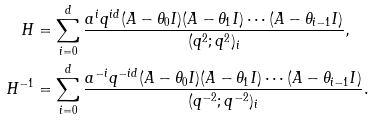<formula> <loc_0><loc_0><loc_500><loc_500>H & = \sum _ { i = 0 } ^ { d } \frac { a ^ { i } q ^ { i d } ( A - \theta _ { 0 } I ) ( A - \theta _ { 1 } I ) \cdots ( A - \theta _ { i - 1 } I ) } { ( q ^ { 2 } ; q ^ { 2 } ) _ { i } } , \\ H ^ { - 1 } & = \sum _ { i = 0 } ^ { d } \frac { a ^ { - i } q ^ { - i d } ( A - \theta _ { 0 } I ) ( A - \theta _ { 1 } I ) \cdots ( A - \theta _ { i - 1 } I ) } { ( q ^ { - 2 } ; q ^ { - 2 } ) _ { i } } .</formula> 